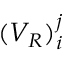<formula> <loc_0><loc_0><loc_500><loc_500>( V _ { R } ) _ { i } ^ { j }</formula> 